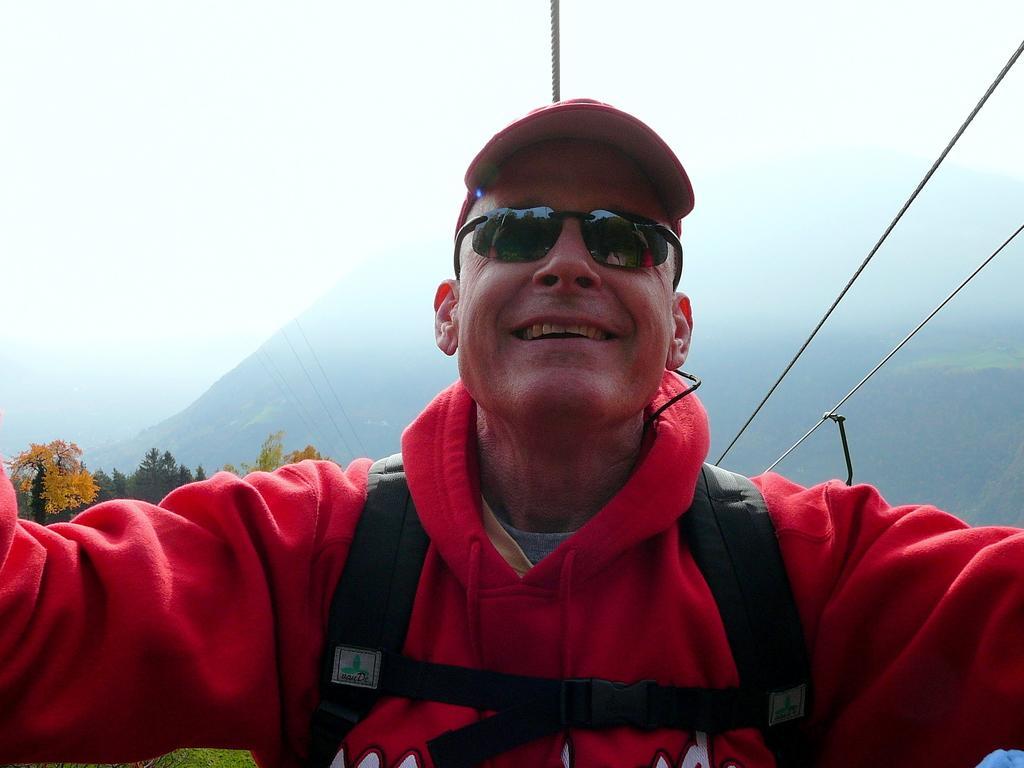In one or two sentences, can you explain what this image depicts? In this image we can see a person. Behind the person we can see trees, mountains and ropes. At the top we can see the sky. 